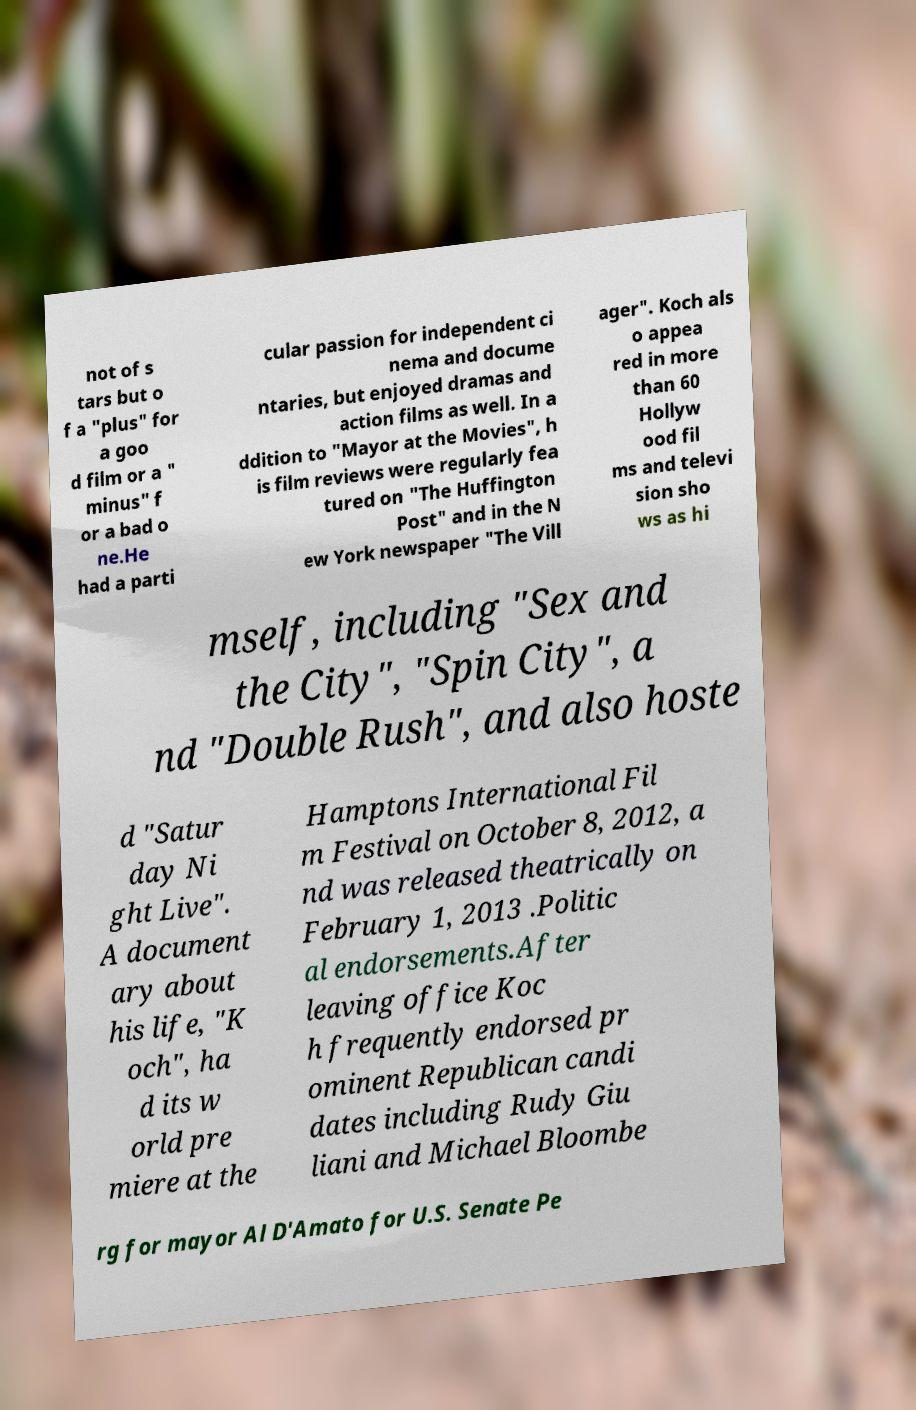Can you accurately transcribe the text from the provided image for me? not of s tars but o f a "plus" for a goo d film or a " minus" f or a bad o ne.He had a parti cular passion for independent ci nema and docume ntaries, but enjoyed dramas and action films as well. In a ddition to "Mayor at the Movies", h is film reviews were regularly fea tured on "The Huffington Post" and in the N ew York newspaper "The Vill ager". Koch als o appea red in more than 60 Hollyw ood fil ms and televi sion sho ws as hi mself, including "Sex and the City", "Spin City", a nd "Double Rush", and also hoste d "Satur day Ni ght Live". A document ary about his life, "K och", ha d its w orld pre miere at the Hamptons International Fil m Festival on October 8, 2012, a nd was released theatrically on February 1, 2013 .Politic al endorsements.After leaving office Koc h frequently endorsed pr ominent Republican candi dates including Rudy Giu liani and Michael Bloombe rg for mayor Al D'Amato for U.S. Senate Pe 